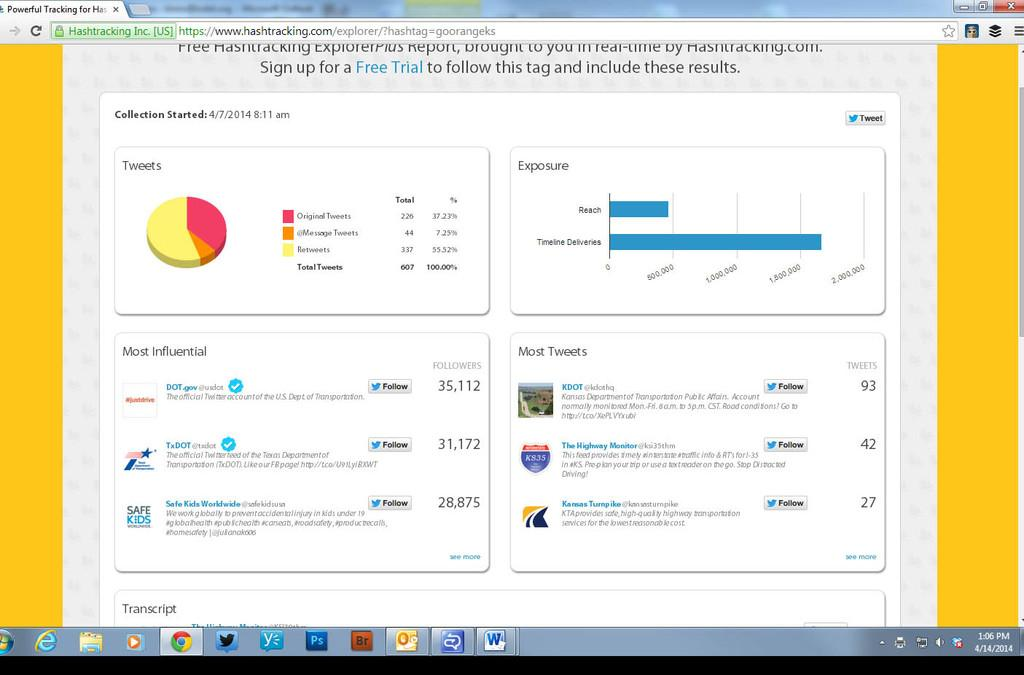What is the main subject of the image? The main subject of the image is a screen of a monitor. What type of information is displayed on the monitor? There are graphs, text, links, buttons, and icons in the image. Can you describe the graphs in the image? Unfortunately, the details of the graphs cannot be determined from the image alone. What might the buttons and links be used for? The buttons and links in the image might be used for navigation or interaction with the displayed content. How many sisters are depicted in the image? There are no people, including sisters, present in the image. What account information is visible in the image? There is no account information visible in the image; it contains graphs, text, links, buttons, and icons related to data or content. 